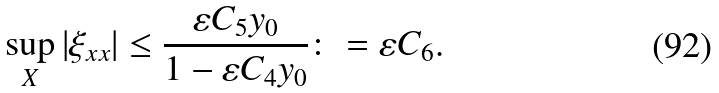<formula> <loc_0><loc_0><loc_500><loc_500>\sup _ { X } | \xi _ { x x } | \leq \frac { \varepsilon C _ { 5 } y _ { 0 } } { 1 - \varepsilon C _ { 4 } y _ { 0 } } \colon = \varepsilon C _ { 6 } .</formula> 